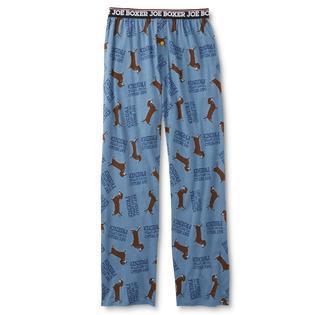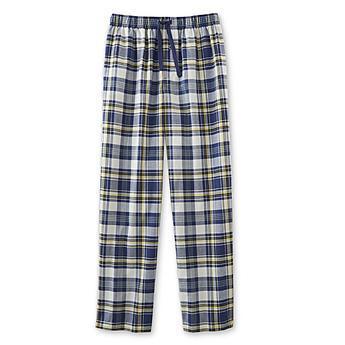The first image is the image on the left, the second image is the image on the right. For the images shown, is this caption "All men's pajama pants have an elastic waist and a drawstring at the center front." true? Answer yes or no. No. 